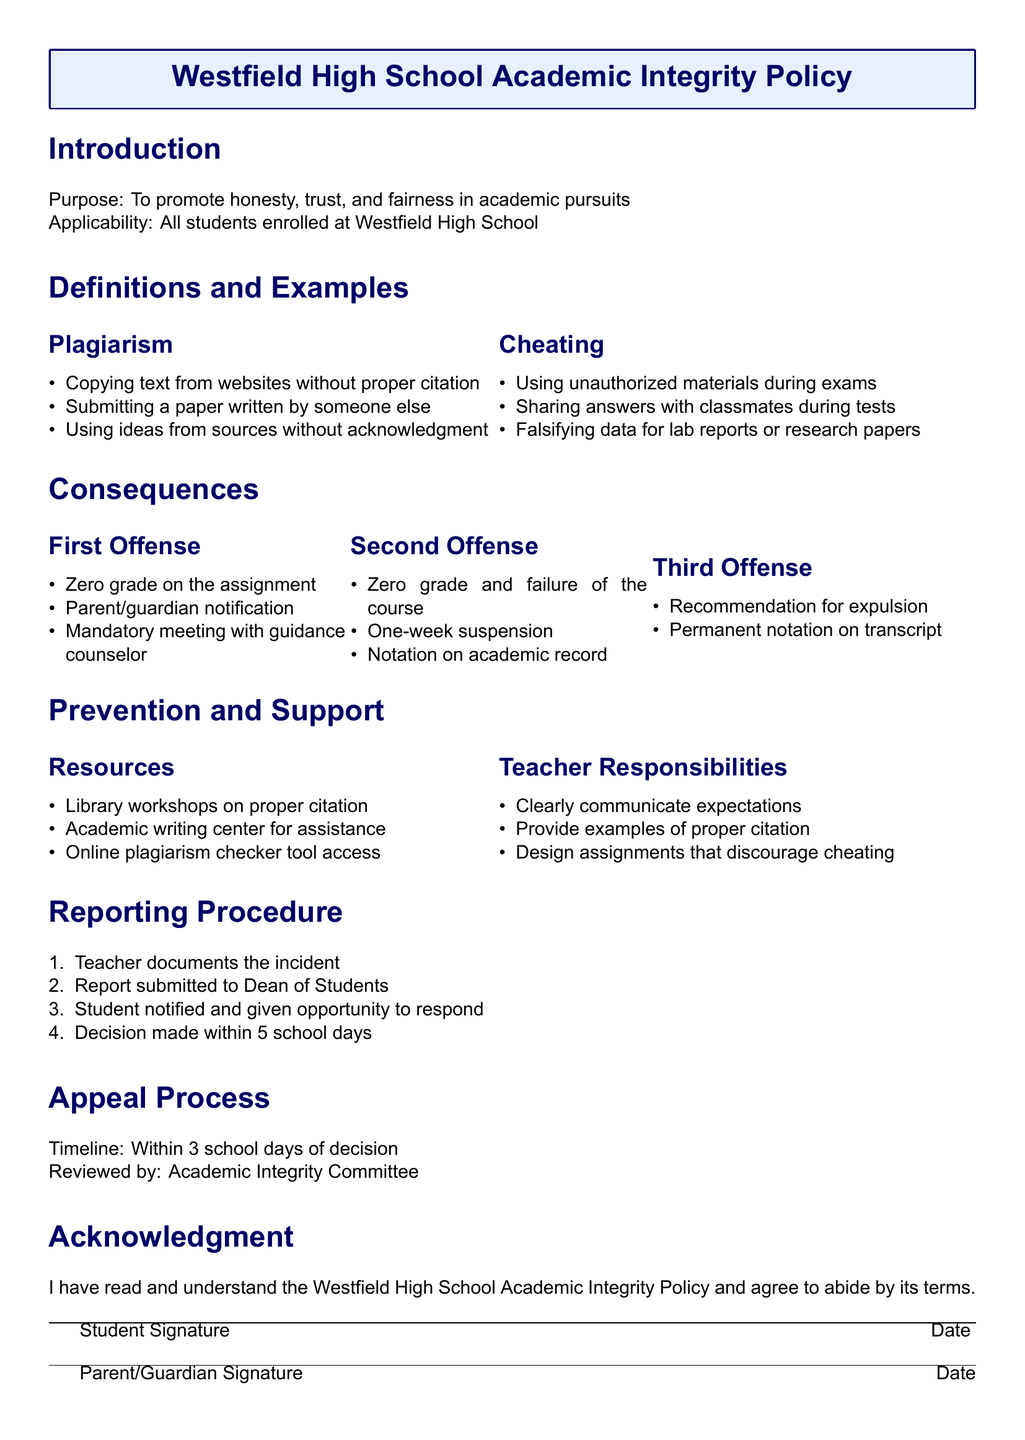What is the purpose of the policy? The purpose is stated at the beginning of the document, promoting honesty, trust, and fairness in academic pursuits.
Answer: To promote honesty, trust, and fairness in academic pursuits What happens on a first offense of plagiarism? The consequences for a first offense are listed under the First Offense section.
Answer: Zero grade on the assignment How long is the suspension for a second offense? The duration of the suspension is provided in the Second Offense consequences.
Answer: One-week suspension What resources are provided to prevent academic dishonesty? Resources are listed in the Prevention and Support section of the document.
Answer: Library workshops on proper citation What is the timeline for the appeal process? The timeline for appealing a decision is specified in the Appeal Process section.
Answer: Within 3 school days of decision What is the recommendation for a third offense? The recommendation is stated in the consequences for a third offense section.
Answer: Recommendation for expulsion 